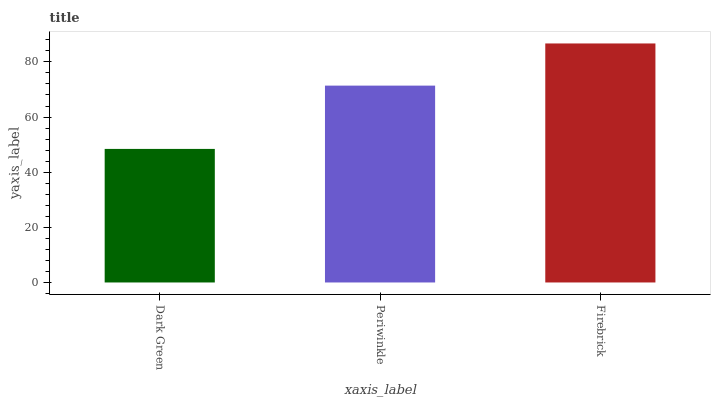Is Dark Green the minimum?
Answer yes or no. Yes. Is Firebrick the maximum?
Answer yes or no. Yes. Is Periwinkle the minimum?
Answer yes or no. No. Is Periwinkle the maximum?
Answer yes or no. No. Is Periwinkle greater than Dark Green?
Answer yes or no. Yes. Is Dark Green less than Periwinkle?
Answer yes or no. Yes. Is Dark Green greater than Periwinkle?
Answer yes or no. No. Is Periwinkle less than Dark Green?
Answer yes or no. No. Is Periwinkle the high median?
Answer yes or no. Yes. Is Periwinkle the low median?
Answer yes or no. Yes. Is Dark Green the high median?
Answer yes or no. No. Is Firebrick the low median?
Answer yes or no. No. 